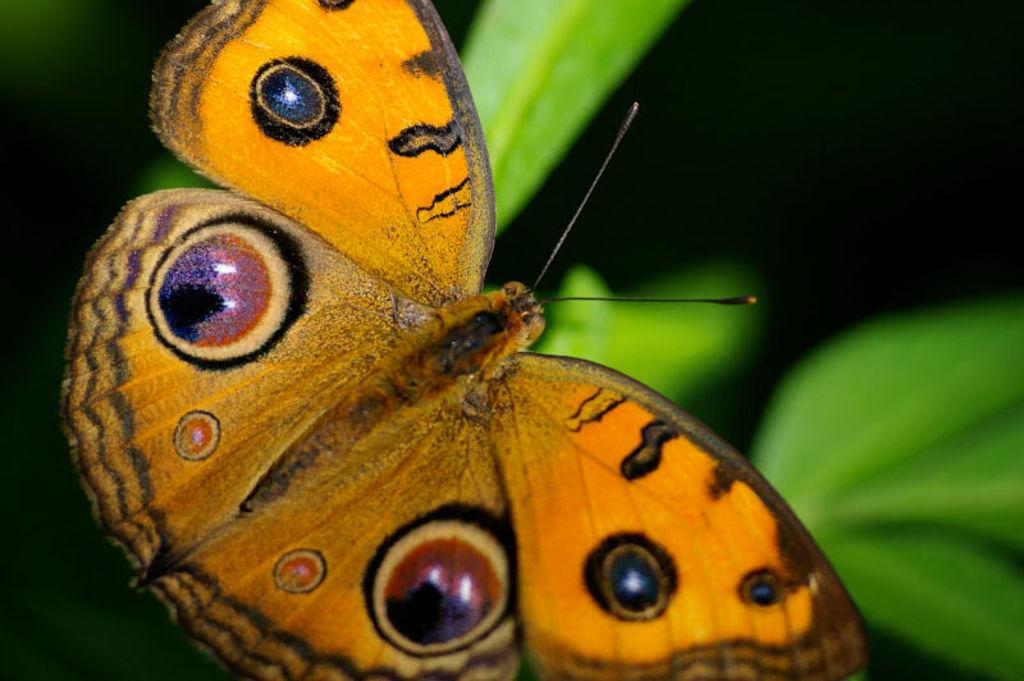What type of insect can be seen in the image? There is a butterfly in the image. What type of plant material is present in the image? There are leaves in the image. What disease is the butterfly suffering from in the image? There is no indication in the image that the butterfly is suffering from any disease. How many birds are present in the flock in the image? There are no birds or flocks present in the image; it features a butterfly and leaves. 